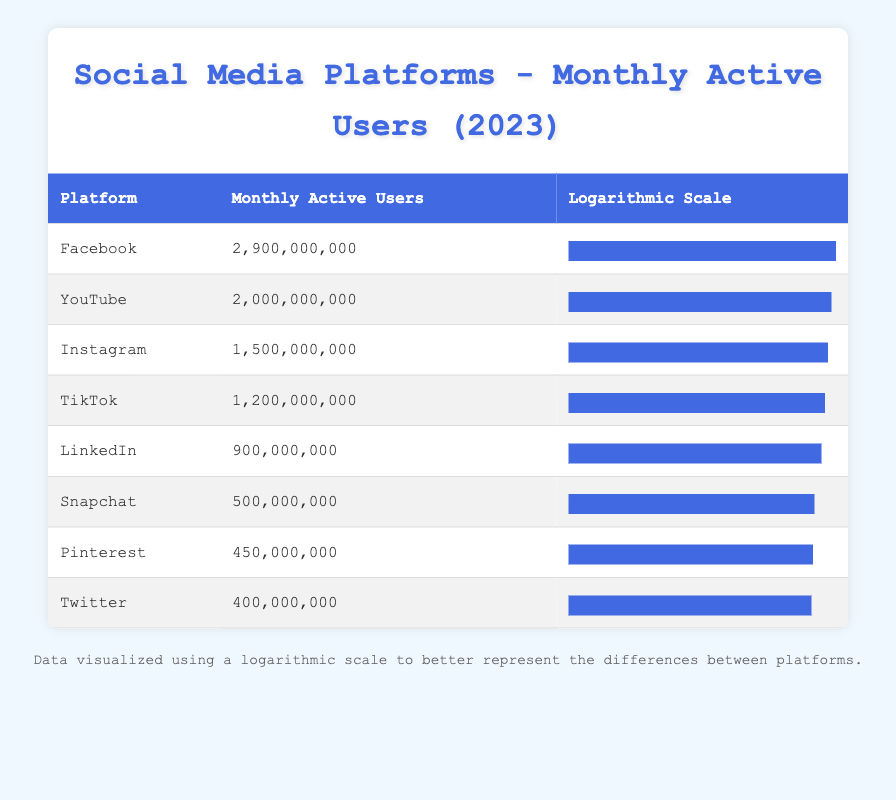What is the Monthly Active Users count of TikTok? The TikTok entry in the table shows that it has 1,200,000,000 Monthly Active Users listed under the "Monthly Active Users" column.
Answer: 1,200,000,000 Which platform has the second highest Monthly Active Users? By looking at the "Monthly Active Users" values, Facebook has 2,900,000,000 users, and YouTube has 2,000,000,000 users, making YouTube the one with the second highest count after Facebook.
Answer: YouTube Is the Monthly Active Users count of Snapchat greater than that of Twitter? The table lists Snapchat with 500,000,000 users and Twitter with 400,000,000 users. Since 500,000,000 is greater than 400,000,000, the answer is yes.
Answer: Yes What is the total Monthly Active Users of the platforms from LinkedIn to Pinterest? The Monthly Active Users for LinkedIn is 900,000,000, Snapchat is 500,000,000, Pinterest is 450,000,000. Adding these gives: 900,000,000 + 500,000,000 + 450,000,000 = 1,850,000,000.
Answer: 1,850,000,000 How many platforms have Monthly Active Users greater than 1 billion? Counting the platforms listed, Facebook (2,900,000,000), YouTube (2,000,000,000), Instagram (1,500,000,000), and TikTok (1,200,000,000) all have more than 1 billion users, making a total of 4 platforms.
Answer: 4 What is the difference in Monthly Active Users between Instagram and LinkedIn? Instagram has 1,500,000,000 users and LinkedIn has 900,000,000 users. The difference is 1,500,000,000 - 900,000,000 = 600,000,000.
Answer: 600,000,000 Which platform has the least Monthly Active Users? The table shows that Twitter has the least Monthly Active Users with a count of 400,000,000, as it is the lowest value listed under the "Monthly Active Users" column.
Answer: Twitter If we consider the above table, is it true that Pinterest has more Monthly Active Users than Snapchat? The Monthly Active Users for Pinterest is listed as 450,000,000 while Snapchat has 500,000,000. Since 450,000,000 is less than 500,000,000, it is not true.
Answer: No What is the average Monthly Active Users for all the platforms listed? To find the average, sum each platform's Monthly Active Users: 2,900M + 2,000M + 1,500M + 1,200M + 400M + 500M + 900M + 450M = 9,850M. There are 8 platforms, so the average is 9,850M / 8 = 1,231,250,000.
Answer: 1,231,250,000 